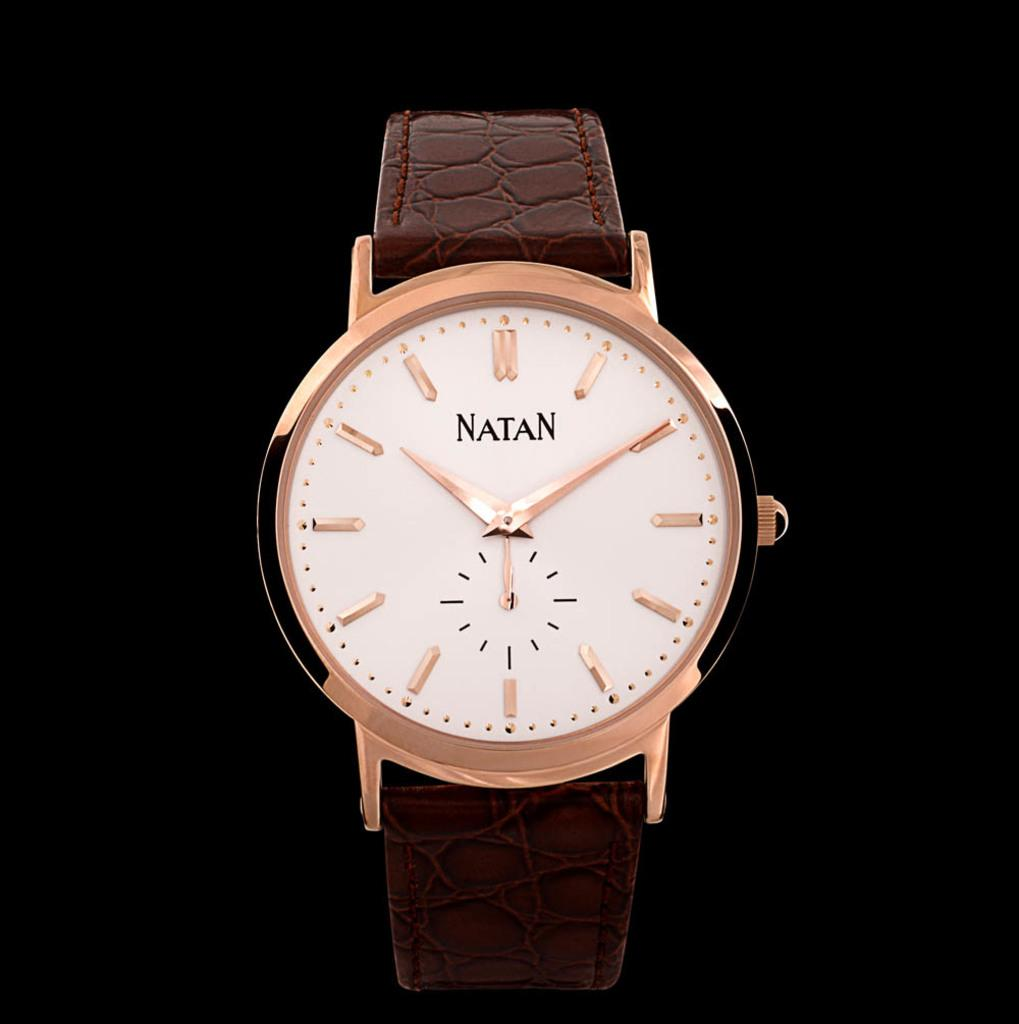<image>
Provide a brief description of the given image. A watch with a brown band and gold trim that is the brand natan. 